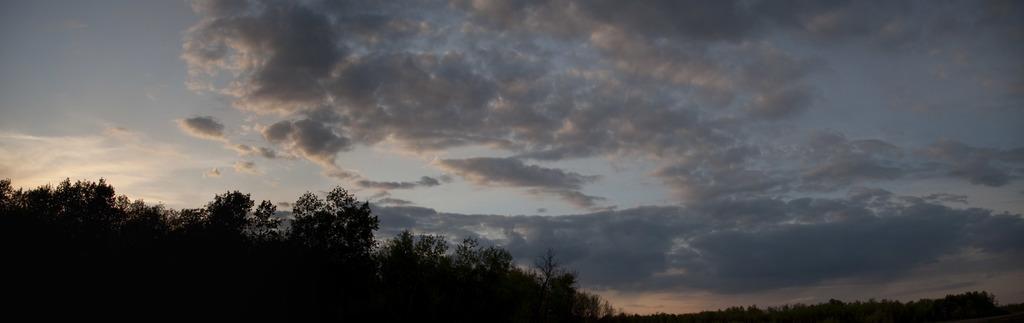Please provide a concise description of this image. In this image I can see number of trees in the front. In the background I can see clouds and the sky. 